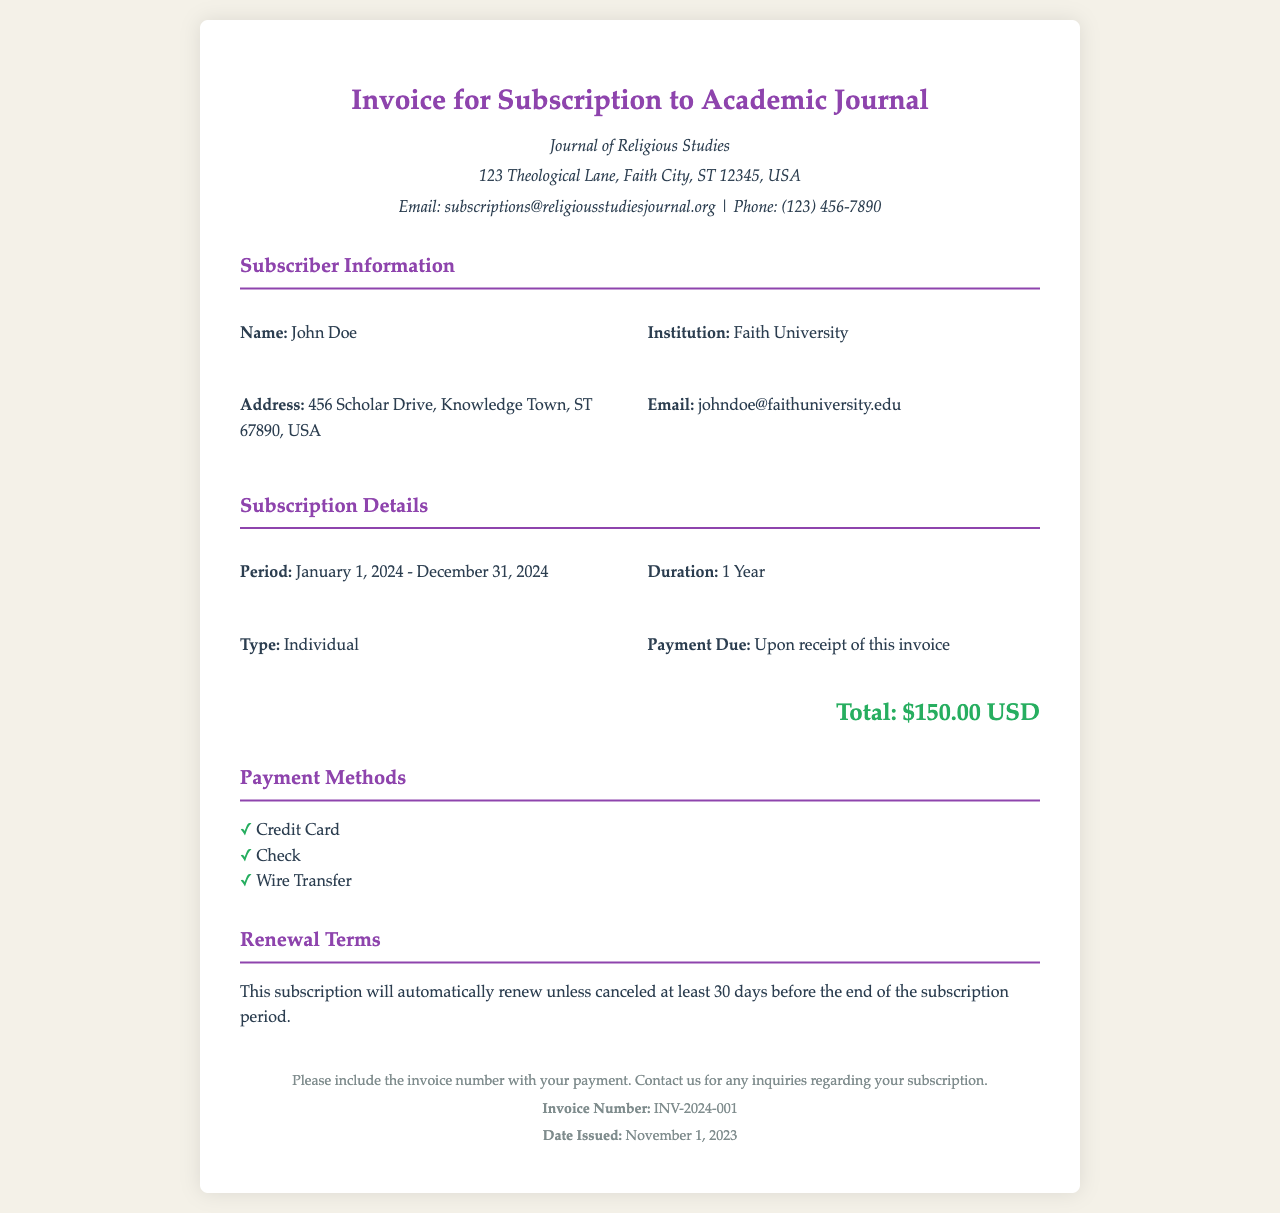What is the name of the subscriber? The subscriber's name is mentioned in the "Subscriber Information" section of the document.
Answer: John Doe What is the total amount due for the subscription? The total amount is specified in the "Subscription Details" section as the overall cost for the subscription period.
Answer: $150.00 USD What is the duration of the subscription? The duration is stated in the "Subscription Details" section, referring to the length of the subscription period.
Answer: 1 Year When does the subscription period start? The start date of the subscription period is provided in the "Subscription Details" section of the document.
Answer: January 1, 2024 What is the payment due date? The due date for payment is specified in the "Subscription Details" section, indicating when payment should be made.
Answer: Upon receipt of this invoice What type of subscription is it? The type of subscription is listed in the "Subscription Details" section, indicating the category of subscription the subscriber is taking.
Answer: Individual What is the renewal policy for this subscription? The renewal terms, which dictate how the subscription will be handled after the end of the current period, are detailed in their own section.
Answer: This subscription will automatically renew unless canceled at least 30 days before the end of the subscription period On what date was the invoice issued? The issue date of the invoice is noted in the "footer" section of the document.
Answer: November 1, 2023 